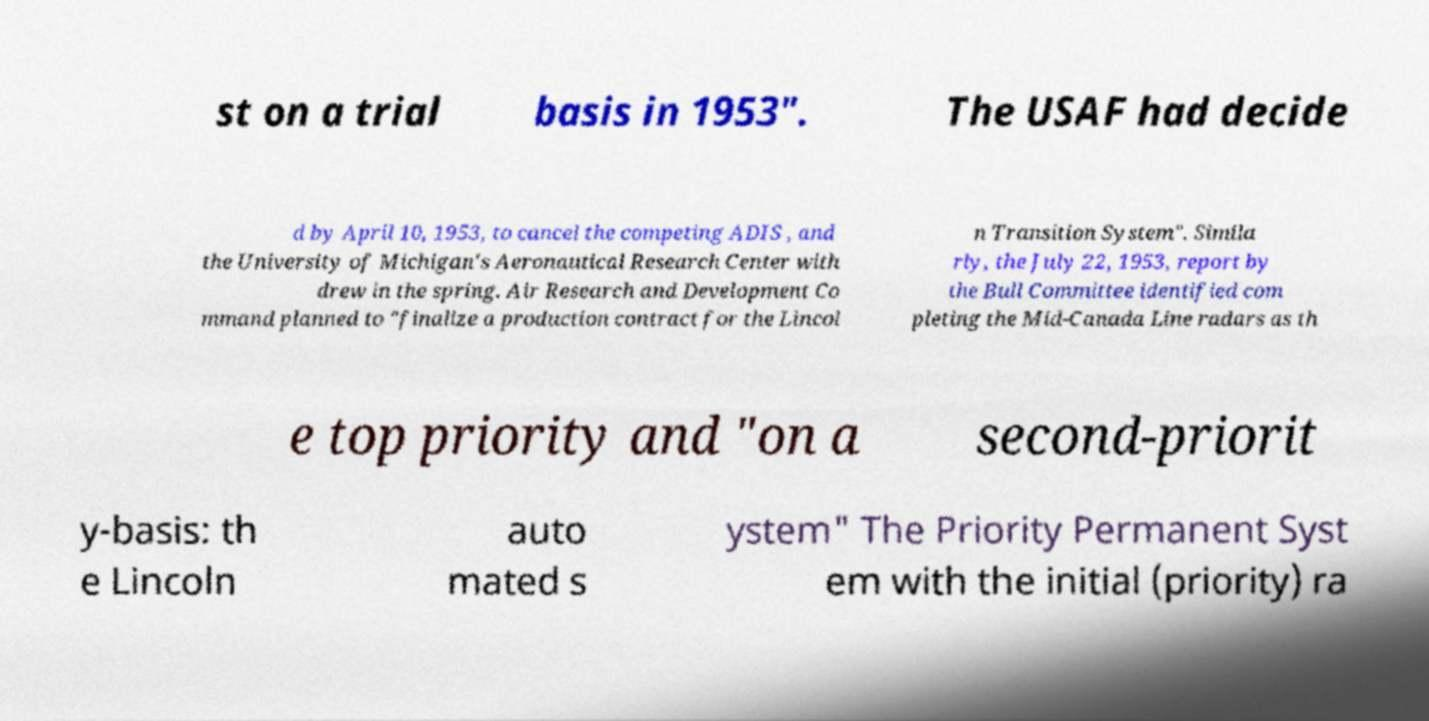Can you read and provide the text displayed in the image?This photo seems to have some interesting text. Can you extract and type it out for me? st on a trial basis in 1953". The USAF had decide d by April 10, 1953, to cancel the competing ADIS , and the University of Michigan's Aeronautical Research Center with drew in the spring. Air Research and Development Co mmand planned to "finalize a production contract for the Lincol n Transition System". Simila rly, the July 22, 1953, report by the Bull Committee identified com pleting the Mid-Canada Line radars as th e top priority and "on a second-priorit y-basis: th e Lincoln auto mated s ystem" The Priority Permanent Syst em with the initial (priority) ra 